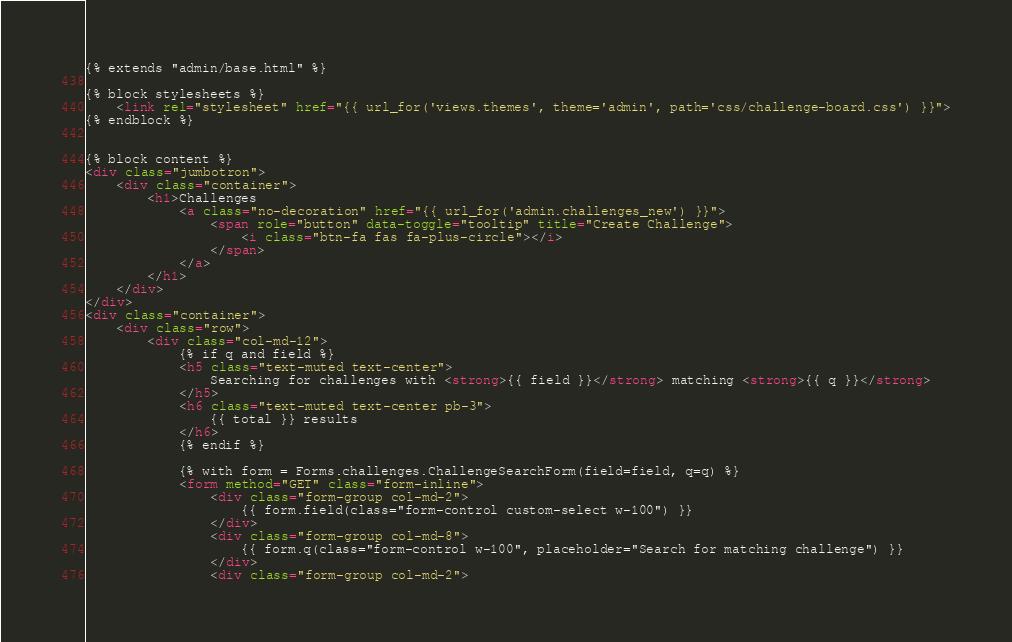Convert code to text. <code><loc_0><loc_0><loc_500><loc_500><_HTML_>{% extends "admin/base.html" %}

{% block stylesheets %}
	<link rel="stylesheet" href="{{ url_for('views.themes', theme='admin', path='css/challenge-board.css') }}">
{% endblock %}


{% block content %}
<div class="jumbotron">
	<div class="container">
		<h1>Challenges
			<a class="no-decoration" href="{{ url_for('admin.challenges_new') }}">
				<span role="button" data-toggle="tooltip" title="Create Challenge">
					<i class="btn-fa fas fa-plus-circle"></i>
				</span>
			</a>
		</h1>
	</div>
</div>
<div class="container">
	<div class="row">
		<div class="col-md-12">
			{% if q and field %}
			<h5 class="text-muted text-center">
				Searching for challenges with <strong>{{ field }}</strong> matching <strong>{{ q }}</strong>
			</h5>
			<h6 class="text-muted text-center pb-3">
				{{ total }} results
			</h6>
			{% endif %}

			{% with form = Forms.challenges.ChallengeSearchForm(field=field, q=q) %}
			<form method="GET" class="form-inline">
				<div class="form-group col-md-2">
					{{ form.field(class="form-control custom-select w-100") }}
				</div>
				<div class="form-group col-md-8">
					{{ form.q(class="form-control w-100", placeholder="Search for matching challenge") }}
				</div>
				<div class="form-group col-md-2"></code> 